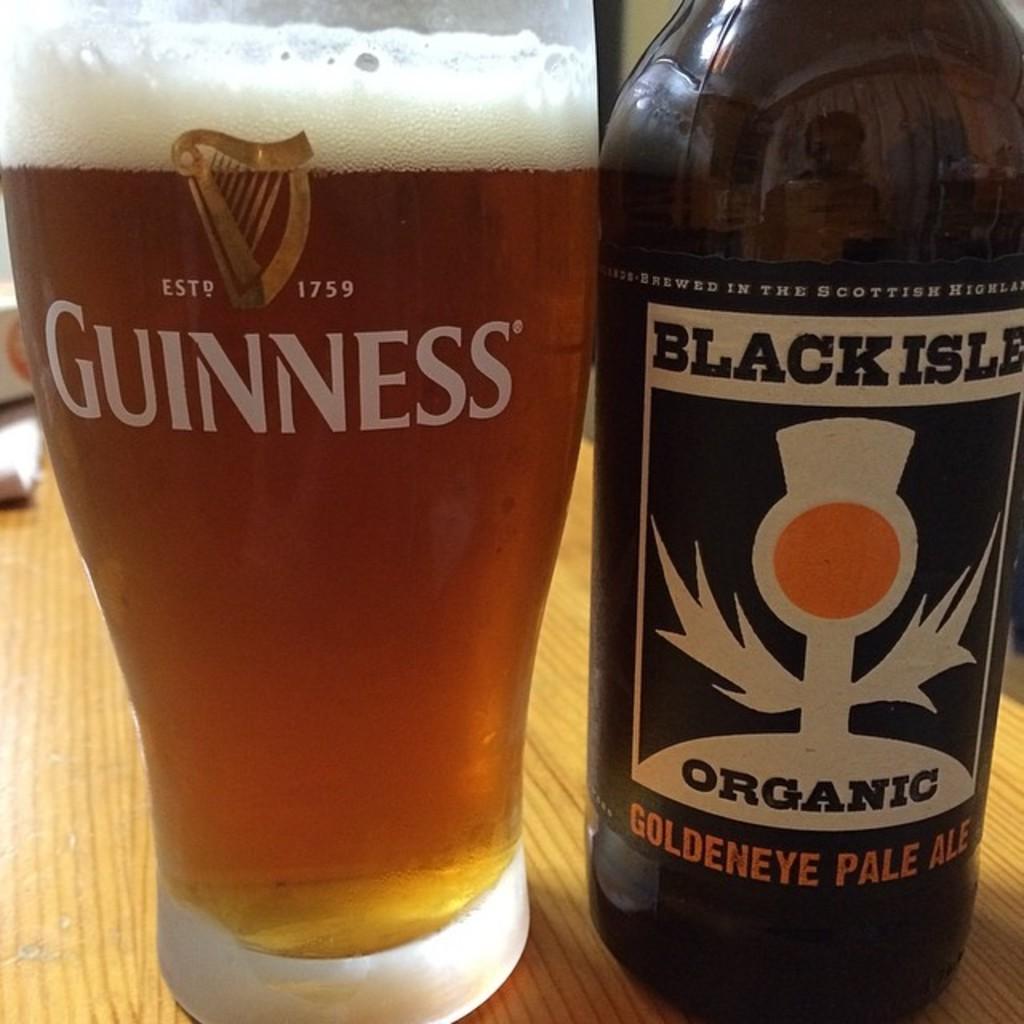Is this ale?
Offer a terse response. Yes. Is the bottle organic?
Provide a succinct answer. Yes. 